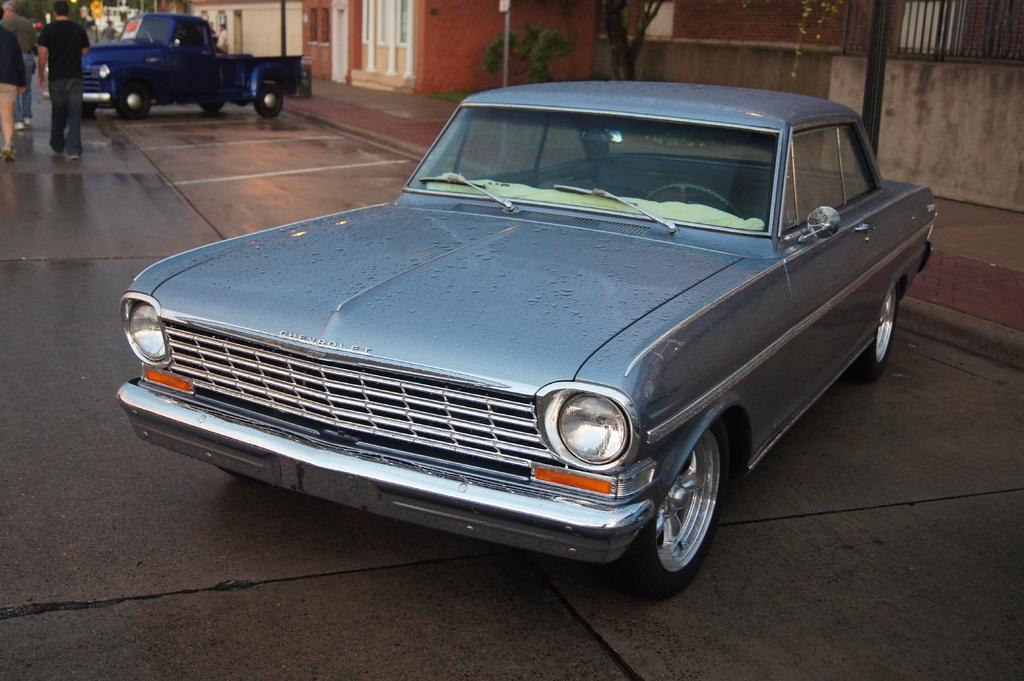What is the main subject in the center of the image? There is a car in the center of the image. What can be seen in the background of the image? Buildings, trees, poles, windows, a truck, people, a road, and a board are visible in the background of the image. Reasoning: Let' Let's think step by step in order to produce the conversation. We start by identifying the main subject in the image, which is the car. Then, we describe the background of the image, mentioning all the elements that are visible. We ensure that each question can be answered definitively with the information given and avoid yes/no questions. Absurd Question/Answer: What type of bead is being used to decorate the car in the image? There is no bead present on the car in the image. Can you tell me how many airplanes are flying in the sky in the image? There are no airplanes visible in the sky in the image. 